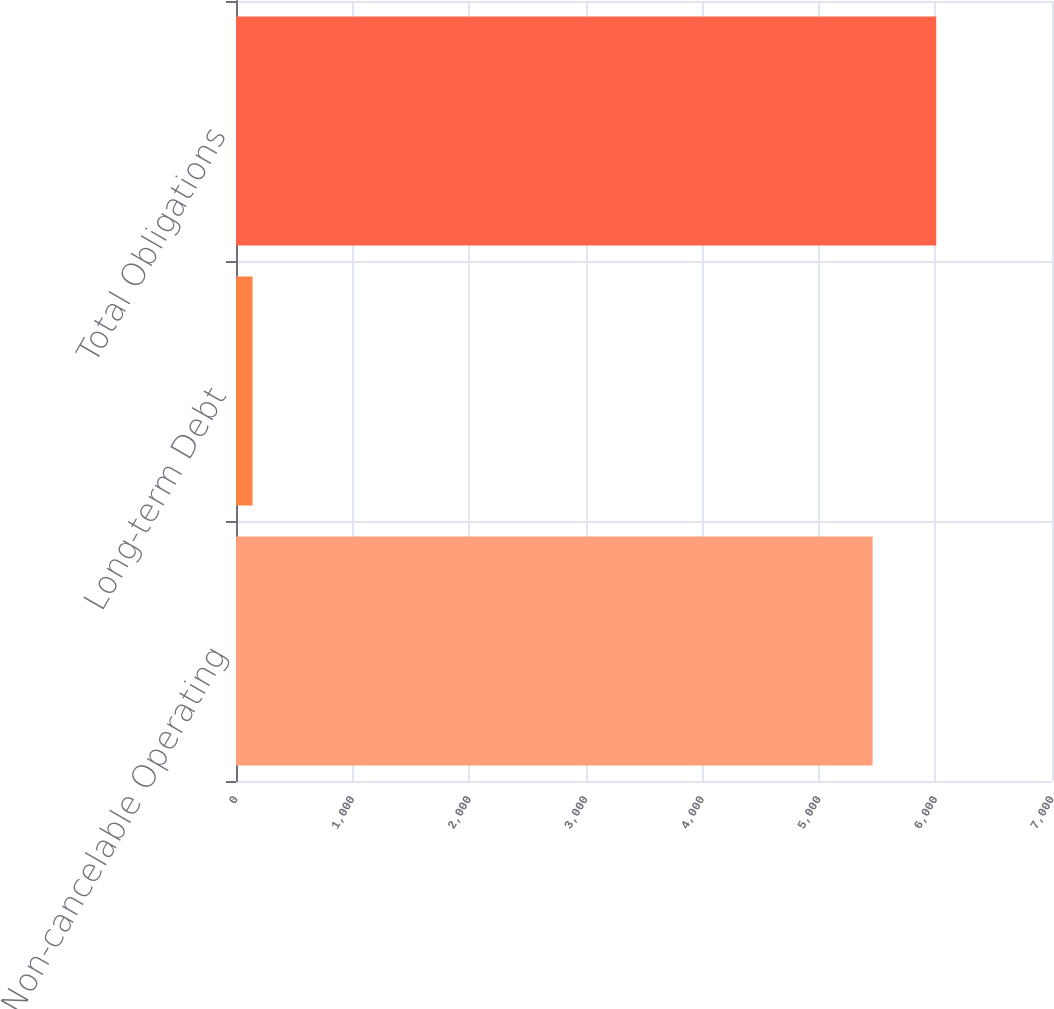Convert chart. <chart><loc_0><loc_0><loc_500><loc_500><bar_chart><fcel>Non-cancelable Operating<fcel>Long-term Debt<fcel>Total Obligations<nl><fcel>5461<fcel>142<fcel>6007.1<nl></chart> 